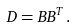Convert formula to latex. <formula><loc_0><loc_0><loc_500><loc_500>D = B B ^ { T } \, .</formula> 